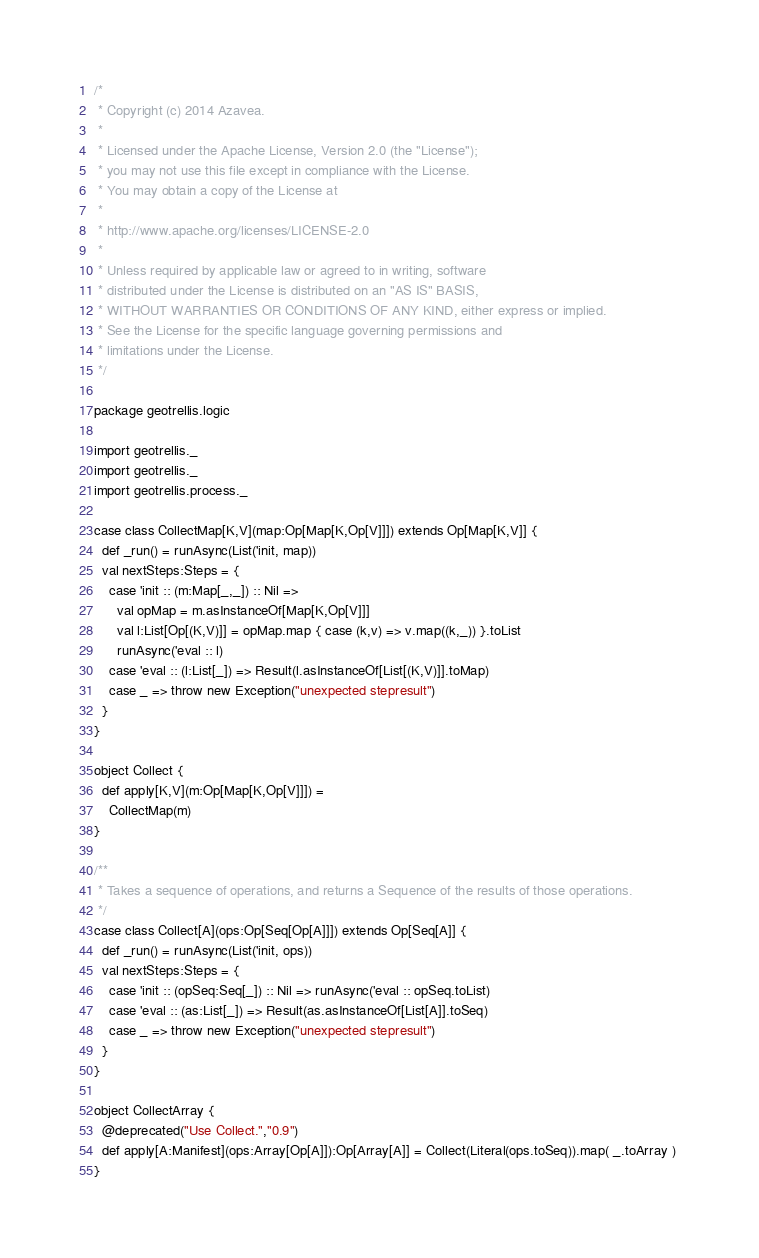<code> <loc_0><loc_0><loc_500><loc_500><_Scala_>/*
 * Copyright (c) 2014 Azavea.
 * 
 * Licensed under the Apache License, Version 2.0 (the "License");
 * you may not use this file except in compliance with the License.
 * You may obtain a copy of the License at
 * 
 * http://www.apache.org/licenses/LICENSE-2.0
 * 
 * Unless required by applicable law or agreed to in writing, software
 * distributed under the License is distributed on an "AS IS" BASIS,
 * WITHOUT WARRANTIES OR CONDITIONS OF ANY KIND, either express or implied.
 * See the License for the specific language governing permissions and
 * limitations under the License.
 */

package geotrellis.logic

import geotrellis._
import geotrellis._
import geotrellis.process._

case class CollectMap[K,V](map:Op[Map[K,Op[V]]]) extends Op[Map[K,V]] {
  def _run() = runAsync(List('init, map)) 
  val nextSteps:Steps = {
    case 'init :: (m:Map[_,_]) :: Nil => 
      val opMap = m.asInstanceOf[Map[K,Op[V]]]
      val l:List[Op[(K,V)]] = opMap.map { case (k,v) => v.map((k,_)) }.toList
      runAsync('eval :: l)
    case 'eval :: (l:List[_]) => Result(l.asInstanceOf[List[(K,V)]].toMap) 
    case _ => throw new Exception("unexpected stepresult")
  }
}

object Collect {
  def apply[K,V](m:Op[Map[K,Op[V]]]) = 
    CollectMap(m)
}

/**
 * Takes a sequence of operations, and returns a Sequence of the results of those operations.
 */
case class Collect[A](ops:Op[Seq[Op[A]]]) extends Op[Seq[A]] {
  def _run() = runAsync(List('init, ops)) 
  val nextSteps:Steps = {
    case 'init :: (opSeq:Seq[_]) :: Nil => runAsync('eval :: opSeq.toList)
    case 'eval :: (as:List[_]) => Result(as.asInstanceOf[List[A]].toSeq) 
    case _ => throw new Exception("unexpected stepresult")
  }
}

object CollectArray {
  @deprecated("Use Collect.","0.9")
  def apply[A:Manifest](ops:Array[Op[A]]):Op[Array[A]] = Collect(Literal(ops.toSeq)).map( _.toArray ) 
}
</code> 